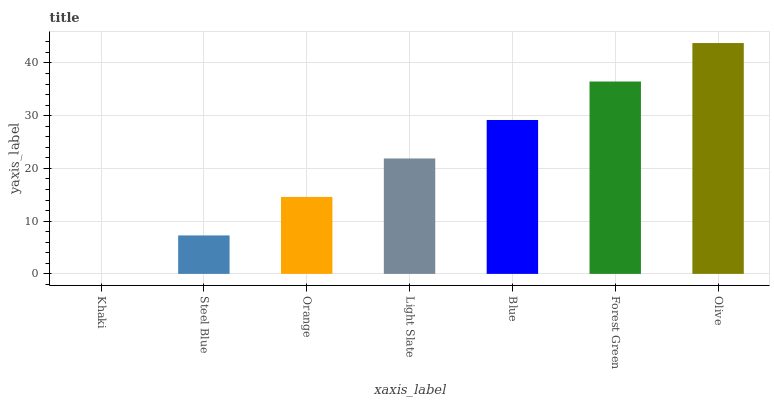Is Steel Blue the minimum?
Answer yes or no. No. Is Steel Blue the maximum?
Answer yes or no. No. Is Steel Blue greater than Khaki?
Answer yes or no. Yes. Is Khaki less than Steel Blue?
Answer yes or no. Yes. Is Khaki greater than Steel Blue?
Answer yes or no. No. Is Steel Blue less than Khaki?
Answer yes or no. No. Is Light Slate the high median?
Answer yes or no. Yes. Is Light Slate the low median?
Answer yes or no. Yes. Is Orange the high median?
Answer yes or no. No. Is Blue the low median?
Answer yes or no. No. 